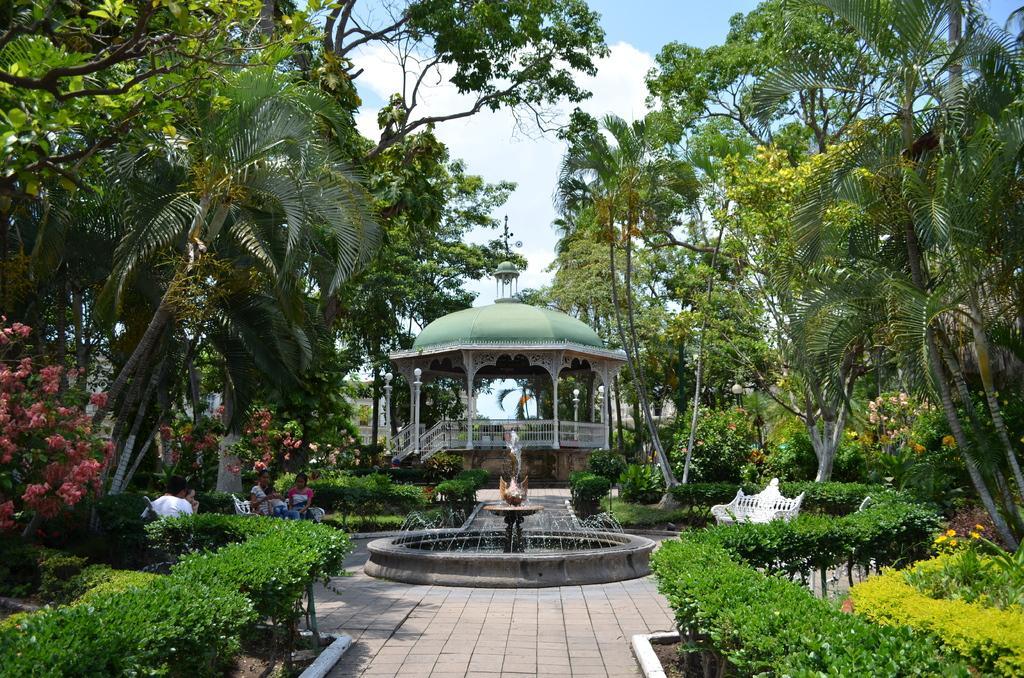In one or two sentences, can you explain what this image depicts? As we can see in the image there are plants, water, benches, few people over here, trees, stairs, fence and sky. In the middle there is fountain. 